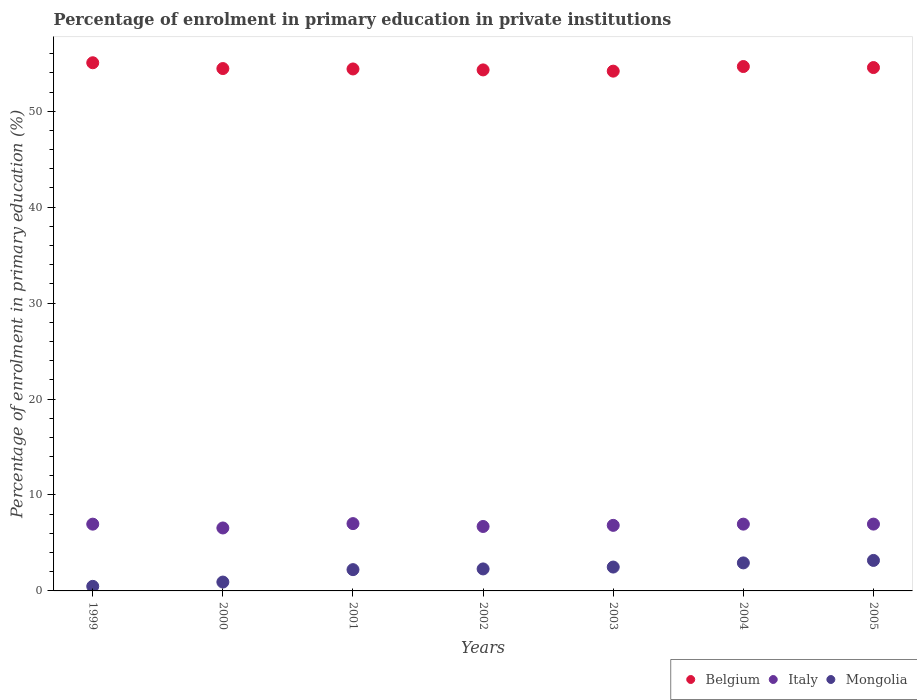What is the percentage of enrolment in primary education in Mongolia in 1999?
Keep it short and to the point. 0.48. Across all years, what is the maximum percentage of enrolment in primary education in Mongolia?
Offer a very short reply. 3.18. Across all years, what is the minimum percentage of enrolment in primary education in Belgium?
Provide a succinct answer. 54.18. In which year was the percentage of enrolment in primary education in Mongolia minimum?
Your response must be concise. 1999. What is the total percentage of enrolment in primary education in Italy in the graph?
Your response must be concise. 48.02. What is the difference between the percentage of enrolment in primary education in Italy in 2002 and that in 2005?
Provide a succinct answer. -0.25. What is the difference between the percentage of enrolment in primary education in Belgium in 2004 and the percentage of enrolment in primary education in Italy in 2003?
Your response must be concise. 47.83. What is the average percentage of enrolment in primary education in Belgium per year?
Offer a terse response. 54.52. In the year 2003, what is the difference between the percentage of enrolment in primary education in Belgium and percentage of enrolment in primary education in Mongolia?
Your answer should be very brief. 51.69. What is the ratio of the percentage of enrolment in primary education in Mongolia in 2002 to that in 2004?
Give a very brief answer. 0.79. Is the difference between the percentage of enrolment in primary education in Belgium in 1999 and 2005 greater than the difference between the percentage of enrolment in primary education in Mongolia in 1999 and 2005?
Ensure brevity in your answer.  Yes. What is the difference between the highest and the second highest percentage of enrolment in primary education in Belgium?
Provide a succinct answer. 0.39. What is the difference between the highest and the lowest percentage of enrolment in primary education in Belgium?
Your answer should be very brief. 0.87. In how many years, is the percentage of enrolment in primary education in Mongolia greater than the average percentage of enrolment in primary education in Mongolia taken over all years?
Your answer should be very brief. 5. Does the graph contain grids?
Make the answer very short. No. Where does the legend appear in the graph?
Your answer should be very brief. Bottom right. How many legend labels are there?
Offer a terse response. 3. What is the title of the graph?
Offer a terse response. Percentage of enrolment in primary education in private institutions. What is the label or title of the Y-axis?
Your answer should be compact. Percentage of enrolment in primary education (%). What is the Percentage of enrolment in primary education (%) of Belgium in 1999?
Your answer should be compact. 55.05. What is the Percentage of enrolment in primary education (%) in Italy in 1999?
Offer a very short reply. 6.96. What is the Percentage of enrolment in primary education (%) of Mongolia in 1999?
Provide a short and direct response. 0.48. What is the Percentage of enrolment in primary education (%) in Belgium in 2000?
Provide a short and direct response. 54.45. What is the Percentage of enrolment in primary education (%) in Italy in 2000?
Your response must be concise. 6.56. What is the Percentage of enrolment in primary education (%) in Mongolia in 2000?
Keep it short and to the point. 0.92. What is the Percentage of enrolment in primary education (%) of Belgium in 2001?
Make the answer very short. 54.41. What is the Percentage of enrolment in primary education (%) of Italy in 2001?
Your answer should be very brief. 7.02. What is the Percentage of enrolment in primary education (%) of Mongolia in 2001?
Your answer should be very brief. 2.22. What is the Percentage of enrolment in primary education (%) in Belgium in 2002?
Offer a very short reply. 54.31. What is the Percentage of enrolment in primary education (%) of Italy in 2002?
Provide a short and direct response. 6.72. What is the Percentage of enrolment in primary education (%) in Mongolia in 2002?
Provide a short and direct response. 2.29. What is the Percentage of enrolment in primary education (%) of Belgium in 2003?
Offer a terse response. 54.18. What is the Percentage of enrolment in primary education (%) in Italy in 2003?
Keep it short and to the point. 6.83. What is the Percentage of enrolment in primary education (%) in Mongolia in 2003?
Your answer should be compact. 2.49. What is the Percentage of enrolment in primary education (%) in Belgium in 2004?
Your response must be concise. 54.66. What is the Percentage of enrolment in primary education (%) of Italy in 2004?
Make the answer very short. 6.96. What is the Percentage of enrolment in primary education (%) in Mongolia in 2004?
Provide a succinct answer. 2.92. What is the Percentage of enrolment in primary education (%) of Belgium in 2005?
Your answer should be very brief. 54.55. What is the Percentage of enrolment in primary education (%) of Italy in 2005?
Your answer should be compact. 6.97. What is the Percentage of enrolment in primary education (%) of Mongolia in 2005?
Keep it short and to the point. 3.18. Across all years, what is the maximum Percentage of enrolment in primary education (%) in Belgium?
Your response must be concise. 55.05. Across all years, what is the maximum Percentage of enrolment in primary education (%) in Italy?
Your response must be concise. 7.02. Across all years, what is the maximum Percentage of enrolment in primary education (%) in Mongolia?
Your response must be concise. 3.18. Across all years, what is the minimum Percentage of enrolment in primary education (%) in Belgium?
Make the answer very short. 54.18. Across all years, what is the minimum Percentage of enrolment in primary education (%) of Italy?
Offer a very short reply. 6.56. Across all years, what is the minimum Percentage of enrolment in primary education (%) of Mongolia?
Give a very brief answer. 0.48. What is the total Percentage of enrolment in primary education (%) of Belgium in the graph?
Keep it short and to the point. 381.61. What is the total Percentage of enrolment in primary education (%) of Italy in the graph?
Offer a very short reply. 48.02. What is the total Percentage of enrolment in primary education (%) of Mongolia in the graph?
Make the answer very short. 14.5. What is the difference between the Percentage of enrolment in primary education (%) of Belgium in 1999 and that in 2000?
Provide a succinct answer. 0.6. What is the difference between the Percentage of enrolment in primary education (%) of Italy in 1999 and that in 2000?
Your answer should be compact. 0.4. What is the difference between the Percentage of enrolment in primary education (%) of Mongolia in 1999 and that in 2000?
Your answer should be compact. -0.45. What is the difference between the Percentage of enrolment in primary education (%) of Belgium in 1999 and that in 2001?
Your answer should be very brief. 0.65. What is the difference between the Percentage of enrolment in primary education (%) in Italy in 1999 and that in 2001?
Keep it short and to the point. -0.06. What is the difference between the Percentage of enrolment in primary education (%) of Mongolia in 1999 and that in 2001?
Provide a succinct answer. -1.74. What is the difference between the Percentage of enrolment in primary education (%) in Belgium in 1999 and that in 2002?
Offer a very short reply. 0.75. What is the difference between the Percentage of enrolment in primary education (%) in Italy in 1999 and that in 2002?
Ensure brevity in your answer.  0.24. What is the difference between the Percentage of enrolment in primary education (%) in Mongolia in 1999 and that in 2002?
Give a very brief answer. -1.82. What is the difference between the Percentage of enrolment in primary education (%) in Belgium in 1999 and that in 2003?
Keep it short and to the point. 0.87. What is the difference between the Percentage of enrolment in primary education (%) in Italy in 1999 and that in 2003?
Make the answer very short. 0.13. What is the difference between the Percentage of enrolment in primary education (%) of Mongolia in 1999 and that in 2003?
Your answer should be compact. -2.01. What is the difference between the Percentage of enrolment in primary education (%) of Belgium in 1999 and that in 2004?
Keep it short and to the point. 0.39. What is the difference between the Percentage of enrolment in primary education (%) in Italy in 1999 and that in 2004?
Give a very brief answer. -0. What is the difference between the Percentage of enrolment in primary education (%) of Mongolia in 1999 and that in 2004?
Provide a short and direct response. -2.44. What is the difference between the Percentage of enrolment in primary education (%) of Belgium in 1999 and that in 2005?
Your response must be concise. 0.5. What is the difference between the Percentage of enrolment in primary education (%) of Italy in 1999 and that in 2005?
Provide a succinct answer. -0.01. What is the difference between the Percentage of enrolment in primary education (%) of Mongolia in 1999 and that in 2005?
Provide a short and direct response. -2.7. What is the difference between the Percentage of enrolment in primary education (%) of Belgium in 2000 and that in 2001?
Ensure brevity in your answer.  0.04. What is the difference between the Percentage of enrolment in primary education (%) of Italy in 2000 and that in 2001?
Your answer should be compact. -0.45. What is the difference between the Percentage of enrolment in primary education (%) in Mongolia in 2000 and that in 2001?
Ensure brevity in your answer.  -1.29. What is the difference between the Percentage of enrolment in primary education (%) in Belgium in 2000 and that in 2002?
Provide a succinct answer. 0.14. What is the difference between the Percentage of enrolment in primary education (%) in Italy in 2000 and that in 2002?
Your answer should be compact. -0.16. What is the difference between the Percentage of enrolment in primary education (%) in Mongolia in 2000 and that in 2002?
Your response must be concise. -1.37. What is the difference between the Percentage of enrolment in primary education (%) in Belgium in 2000 and that in 2003?
Provide a succinct answer. 0.27. What is the difference between the Percentage of enrolment in primary education (%) in Italy in 2000 and that in 2003?
Provide a succinct answer. -0.27. What is the difference between the Percentage of enrolment in primary education (%) in Mongolia in 2000 and that in 2003?
Give a very brief answer. -1.56. What is the difference between the Percentage of enrolment in primary education (%) of Belgium in 2000 and that in 2004?
Provide a short and direct response. -0.21. What is the difference between the Percentage of enrolment in primary education (%) of Italy in 2000 and that in 2004?
Give a very brief answer. -0.4. What is the difference between the Percentage of enrolment in primary education (%) in Mongolia in 2000 and that in 2004?
Your answer should be compact. -2. What is the difference between the Percentage of enrolment in primary education (%) of Belgium in 2000 and that in 2005?
Offer a terse response. -0.1. What is the difference between the Percentage of enrolment in primary education (%) of Italy in 2000 and that in 2005?
Give a very brief answer. -0.4. What is the difference between the Percentage of enrolment in primary education (%) in Mongolia in 2000 and that in 2005?
Make the answer very short. -2.26. What is the difference between the Percentage of enrolment in primary education (%) in Belgium in 2001 and that in 2002?
Offer a terse response. 0.1. What is the difference between the Percentage of enrolment in primary education (%) of Italy in 2001 and that in 2002?
Provide a short and direct response. 0.3. What is the difference between the Percentage of enrolment in primary education (%) in Mongolia in 2001 and that in 2002?
Your response must be concise. -0.08. What is the difference between the Percentage of enrolment in primary education (%) in Belgium in 2001 and that in 2003?
Give a very brief answer. 0.23. What is the difference between the Percentage of enrolment in primary education (%) in Italy in 2001 and that in 2003?
Make the answer very short. 0.18. What is the difference between the Percentage of enrolment in primary education (%) in Mongolia in 2001 and that in 2003?
Provide a succinct answer. -0.27. What is the difference between the Percentage of enrolment in primary education (%) in Belgium in 2001 and that in 2004?
Give a very brief answer. -0.25. What is the difference between the Percentage of enrolment in primary education (%) of Italy in 2001 and that in 2004?
Ensure brevity in your answer.  0.05. What is the difference between the Percentage of enrolment in primary education (%) in Mongolia in 2001 and that in 2004?
Provide a succinct answer. -0.7. What is the difference between the Percentage of enrolment in primary education (%) of Belgium in 2001 and that in 2005?
Make the answer very short. -0.15. What is the difference between the Percentage of enrolment in primary education (%) of Italy in 2001 and that in 2005?
Give a very brief answer. 0.05. What is the difference between the Percentage of enrolment in primary education (%) of Mongolia in 2001 and that in 2005?
Keep it short and to the point. -0.96. What is the difference between the Percentage of enrolment in primary education (%) of Belgium in 2002 and that in 2003?
Your answer should be very brief. 0.13. What is the difference between the Percentage of enrolment in primary education (%) in Italy in 2002 and that in 2003?
Offer a very short reply. -0.12. What is the difference between the Percentage of enrolment in primary education (%) in Mongolia in 2002 and that in 2003?
Provide a succinct answer. -0.19. What is the difference between the Percentage of enrolment in primary education (%) of Belgium in 2002 and that in 2004?
Provide a short and direct response. -0.35. What is the difference between the Percentage of enrolment in primary education (%) in Italy in 2002 and that in 2004?
Offer a very short reply. -0.24. What is the difference between the Percentage of enrolment in primary education (%) in Mongolia in 2002 and that in 2004?
Provide a short and direct response. -0.63. What is the difference between the Percentage of enrolment in primary education (%) of Belgium in 2002 and that in 2005?
Your answer should be very brief. -0.25. What is the difference between the Percentage of enrolment in primary education (%) of Italy in 2002 and that in 2005?
Your answer should be compact. -0.25. What is the difference between the Percentage of enrolment in primary education (%) of Mongolia in 2002 and that in 2005?
Make the answer very short. -0.89. What is the difference between the Percentage of enrolment in primary education (%) in Belgium in 2003 and that in 2004?
Make the answer very short. -0.48. What is the difference between the Percentage of enrolment in primary education (%) of Italy in 2003 and that in 2004?
Provide a succinct answer. -0.13. What is the difference between the Percentage of enrolment in primary education (%) in Mongolia in 2003 and that in 2004?
Your answer should be very brief. -0.43. What is the difference between the Percentage of enrolment in primary education (%) in Belgium in 2003 and that in 2005?
Provide a short and direct response. -0.37. What is the difference between the Percentage of enrolment in primary education (%) in Italy in 2003 and that in 2005?
Make the answer very short. -0.13. What is the difference between the Percentage of enrolment in primary education (%) in Mongolia in 2003 and that in 2005?
Offer a terse response. -0.69. What is the difference between the Percentage of enrolment in primary education (%) of Belgium in 2004 and that in 2005?
Make the answer very short. 0.11. What is the difference between the Percentage of enrolment in primary education (%) in Italy in 2004 and that in 2005?
Give a very brief answer. -0. What is the difference between the Percentage of enrolment in primary education (%) of Mongolia in 2004 and that in 2005?
Provide a short and direct response. -0.26. What is the difference between the Percentage of enrolment in primary education (%) of Belgium in 1999 and the Percentage of enrolment in primary education (%) of Italy in 2000?
Your answer should be very brief. 48.49. What is the difference between the Percentage of enrolment in primary education (%) in Belgium in 1999 and the Percentage of enrolment in primary education (%) in Mongolia in 2000?
Give a very brief answer. 54.13. What is the difference between the Percentage of enrolment in primary education (%) in Italy in 1999 and the Percentage of enrolment in primary education (%) in Mongolia in 2000?
Offer a terse response. 6.04. What is the difference between the Percentage of enrolment in primary education (%) of Belgium in 1999 and the Percentage of enrolment in primary education (%) of Italy in 2001?
Offer a terse response. 48.04. What is the difference between the Percentage of enrolment in primary education (%) of Belgium in 1999 and the Percentage of enrolment in primary education (%) of Mongolia in 2001?
Offer a very short reply. 52.84. What is the difference between the Percentage of enrolment in primary education (%) in Italy in 1999 and the Percentage of enrolment in primary education (%) in Mongolia in 2001?
Make the answer very short. 4.74. What is the difference between the Percentage of enrolment in primary education (%) of Belgium in 1999 and the Percentage of enrolment in primary education (%) of Italy in 2002?
Provide a short and direct response. 48.34. What is the difference between the Percentage of enrolment in primary education (%) in Belgium in 1999 and the Percentage of enrolment in primary education (%) in Mongolia in 2002?
Offer a very short reply. 52.76. What is the difference between the Percentage of enrolment in primary education (%) of Italy in 1999 and the Percentage of enrolment in primary education (%) of Mongolia in 2002?
Give a very brief answer. 4.67. What is the difference between the Percentage of enrolment in primary education (%) of Belgium in 1999 and the Percentage of enrolment in primary education (%) of Italy in 2003?
Give a very brief answer. 48.22. What is the difference between the Percentage of enrolment in primary education (%) in Belgium in 1999 and the Percentage of enrolment in primary education (%) in Mongolia in 2003?
Give a very brief answer. 52.57. What is the difference between the Percentage of enrolment in primary education (%) in Italy in 1999 and the Percentage of enrolment in primary education (%) in Mongolia in 2003?
Give a very brief answer. 4.47. What is the difference between the Percentage of enrolment in primary education (%) in Belgium in 1999 and the Percentage of enrolment in primary education (%) in Italy in 2004?
Keep it short and to the point. 48.09. What is the difference between the Percentage of enrolment in primary education (%) in Belgium in 1999 and the Percentage of enrolment in primary education (%) in Mongolia in 2004?
Your answer should be compact. 52.13. What is the difference between the Percentage of enrolment in primary education (%) of Italy in 1999 and the Percentage of enrolment in primary education (%) of Mongolia in 2004?
Keep it short and to the point. 4.04. What is the difference between the Percentage of enrolment in primary education (%) in Belgium in 1999 and the Percentage of enrolment in primary education (%) in Italy in 2005?
Your answer should be very brief. 48.09. What is the difference between the Percentage of enrolment in primary education (%) of Belgium in 1999 and the Percentage of enrolment in primary education (%) of Mongolia in 2005?
Keep it short and to the point. 51.87. What is the difference between the Percentage of enrolment in primary education (%) in Italy in 1999 and the Percentage of enrolment in primary education (%) in Mongolia in 2005?
Offer a terse response. 3.78. What is the difference between the Percentage of enrolment in primary education (%) in Belgium in 2000 and the Percentage of enrolment in primary education (%) in Italy in 2001?
Your response must be concise. 47.43. What is the difference between the Percentage of enrolment in primary education (%) of Belgium in 2000 and the Percentage of enrolment in primary education (%) of Mongolia in 2001?
Provide a short and direct response. 52.23. What is the difference between the Percentage of enrolment in primary education (%) in Italy in 2000 and the Percentage of enrolment in primary education (%) in Mongolia in 2001?
Ensure brevity in your answer.  4.34. What is the difference between the Percentage of enrolment in primary education (%) in Belgium in 2000 and the Percentage of enrolment in primary education (%) in Italy in 2002?
Keep it short and to the point. 47.73. What is the difference between the Percentage of enrolment in primary education (%) of Belgium in 2000 and the Percentage of enrolment in primary education (%) of Mongolia in 2002?
Keep it short and to the point. 52.16. What is the difference between the Percentage of enrolment in primary education (%) in Italy in 2000 and the Percentage of enrolment in primary education (%) in Mongolia in 2002?
Your answer should be compact. 4.27. What is the difference between the Percentage of enrolment in primary education (%) in Belgium in 2000 and the Percentage of enrolment in primary education (%) in Italy in 2003?
Your response must be concise. 47.61. What is the difference between the Percentage of enrolment in primary education (%) of Belgium in 2000 and the Percentage of enrolment in primary education (%) of Mongolia in 2003?
Make the answer very short. 51.96. What is the difference between the Percentage of enrolment in primary education (%) in Italy in 2000 and the Percentage of enrolment in primary education (%) in Mongolia in 2003?
Offer a very short reply. 4.07. What is the difference between the Percentage of enrolment in primary education (%) in Belgium in 2000 and the Percentage of enrolment in primary education (%) in Italy in 2004?
Your answer should be compact. 47.49. What is the difference between the Percentage of enrolment in primary education (%) of Belgium in 2000 and the Percentage of enrolment in primary education (%) of Mongolia in 2004?
Offer a terse response. 51.53. What is the difference between the Percentage of enrolment in primary education (%) in Italy in 2000 and the Percentage of enrolment in primary education (%) in Mongolia in 2004?
Keep it short and to the point. 3.64. What is the difference between the Percentage of enrolment in primary education (%) in Belgium in 2000 and the Percentage of enrolment in primary education (%) in Italy in 2005?
Your answer should be very brief. 47.48. What is the difference between the Percentage of enrolment in primary education (%) of Belgium in 2000 and the Percentage of enrolment in primary education (%) of Mongolia in 2005?
Ensure brevity in your answer.  51.27. What is the difference between the Percentage of enrolment in primary education (%) in Italy in 2000 and the Percentage of enrolment in primary education (%) in Mongolia in 2005?
Your response must be concise. 3.38. What is the difference between the Percentage of enrolment in primary education (%) of Belgium in 2001 and the Percentage of enrolment in primary education (%) of Italy in 2002?
Provide a succinct answer. 47.69. What is the difference between the Percentage of enrolment in primary education (%) in Belgium in 2001 and the Percentage of enrolment in primary education (%) in Mongolia in 2002?
Your answer should be very brief. 52.11. What is the difference between the Percentage of enrolment in primary education (%) in Italy in 2001 and the Percentage of enrolment in primary education (%) in Mongolia in 2002?
Your response must be concise. 4.72. What is the difference between the Percentage of enrolment in primary education (%) of Belgium in 2001 and the Percentage of enrolment in primary education (%) of Italy in 2003?
Your answer should be very brief. 47.57. What is the difference between the Percentage of enrolment in primary education (%) of Belgium in 2001 and the Percentage of enrolment in primary education (%) of Mongolia in 2003?
Your response must be concise. 51.92. What is the difference between the Percentage of enrolment in primary education (%) in Italy in 2001 and the Percentage of enrolment in primary education (%) in Mongolia in 2003?
Your answer should be very brief. 4.53. What is the difference between the Percentage of enrolment in primary education (%) in Belgium in 2001 and the Percentage of enrolment in primary education (%) in Italy in 2004?
Provide a succinct answer. 47.44. What is the difference between the Percentage of enrolment in primary education (%) of Belgium in 2001 and the Percentage of enrolment in primary education (%) of Mongolia in 2004?
Provide a succinct answer. 51.49. What is the difference between the Percentage of enrolment in primary education (%) of Italy in 2001 and the Percentage of enrolment in primary education (%) of Mongolia in 2004?
Give a very brief answer. 4.1. What is the difference between the Percentage of enrolment in primary education (%) of Belgium in 2001 and the Percentage of enrolment in primary education (%) of Italy in 2005?
Your response must be concise. 47.44. What is the difference between the Percentage of enrolment in primary education (%) of Belgium in 2001 and the Percentage of enrolment in primary education (%) of Mongolia in 2005?
Your answer should be compact. 51.23. What is the difference between the Percentage of enrolment in primary education (%) in Italy in 2001 and the Percentage of enrolment in primary education (%) in Mongolia in 2005?
Provide a short and direct response. 3.84. What is the difference between the Percentage of enrolment in primary education (%) in Belgium in 2002 and the Percentage of enrolment in primary education (%) in Italy in 2003?
Give a very brief answer. 47.47. What is the difference between the Percentage of enrolment in primary education (%) of Belgium in 2002 and the Percentage of enrolment in primary education (%) of Mongolia in 2003?
Keep it short and to the point. 51.82. What is the difference between the Percentage of enrolment in primary education (%) in Italy in 2002 and the Percentage of enrolment in primary education (%) in Mongolia in 2003?
Give a very brief answer. 4.23. What is the difference between the Percentage of enrolment in primary education (%) in Belgium in 2002 and the Percentage of enrolment in primary education (%) in Italy in 2004?
Offer a terse response. 47.34. What is the difference between the Percentage of enrolment in primary education (%) of Belgium in 2002 and the Percentage of enrolment in primary education (%) of Mongolia in 2004?
Ensure brevity in your answer.  51.39. What is the difference between the Percentage of enrolment in primary education (%) in Italy in 2002 and the Percentage of enrolment in primary education (%) in Mongolia in 2004?
Offer a very short reply. 3.8. What is the difference between the Percentage of enrolment in primary education (%) in Belgium in 2002 and the Percentage of enrolment in primary education (%) in Italy in 2005?
Give a very brief answer. 47.34. What is the difference between the Percentage of enrolment in primary education (%) in Belgium in 2002 and the Percentage of enrolment in primary education (%) in Mongolia in 2005?
Your answer should be very brief. 51.13. What is the difference between the Percentage of enrolment in primary education (%) of Italy in 2002 and the Percentage of enrolment in primary education (%) of Mongolia in 2005?
Ensure brevity in your answer.  3.54. What is the difference between the Percentage of enrolment in primary education (%) in Belgium in 2003 and the Percentage of enrolment in primary education (%) in Italy in 2004?
Provide a succinct answer. 47.22. What is the difference between the Percentage of enrolment in primary education (%) in Belgium in 2003 and the Percentage of enrolment in primary education (%) in Mongolia in 2004?
Your response must be concise. 51.26. What is the difference between the Percentage of enrolment in primary education (%) of Italy in 2003 and the Percentage of enrolment in primary education (%) of Mongolia in 2004?
Provide a short and direct response. 3.91. What is the difference between the Percentage of enrolment in primary education (%) in Belgium in 2003 and the Percentage of enrolment in primary education (%) in Italy in 2005?
Offer a very short reply. 47.21. What is the difference between the Percentage of enrolment in primary education (%) of Belgium in 2003 and the Percentage of enrolment in primary education (%) of Mongolia in 2005?
Provide a succinct answer. 51. What is the difference between the Percentage of enrolment in primary education (%) of Italy in 2003 and the Percentage of enrolment in primary education (%) of Mongolia in 2005?
Ensure brevity in your answer.  3.65. What is the difference between the Percentage of enrolment in primary education (%) in Belgium in 2004 and the Percentage of enrolment in primary education (%) in Italy in 2005?
Give a very brief answer. 47.69. What is the difference between the Percentage of enrolment in primary education (%) of Belgium in 2004 and the Percentage of enrolment in primary education (%) of Mongolia in 2005?
Offer a very short reply. 51.48. What is the difference between the Percentage of enrolment in primary education (%) of Italy in 2004 and the Percentage of enrolment in primary education (%) of Mongolia in 2005?
Provide a short and direct response. 3.78. What is the average Percentage of enrolment in primary education (%) of Belgium per year?
Provide a short and direct response. 54.52. What is the average Percentage of enrolment in primary education (%) in Italy per year?
Ensure brevity in your answer.  6.86. What is the average Percentage of enrolment in primary education (%) of Mongolia per year?
Make the answer very short. 2.07. In the year 1999, what is the difference between the Percentage of enrolment in primary education (%) of Belgium and Percentage of enrolment in primary education (%) of Italy?
Make the answer very short. 48.09. In the year 1999, what is the difference between the Percentage of enrolment in primary education (%) of Belgium and Percentage of enrolment in primary education (%) of Mongolia?
Keep it short and to the point. 54.58. In the year 1999, what is the difference between the Percentage of enrolment in primary education (%) in Italy and Percentage of enrolment in primary education (%) in Mongolia?
Provide a succinct answer. 6.48. In the year 2000, what is the difference between the Percentage of enrolment in primary education (%) in Belgium and Percentage of enrolment in primary education (%) in Italy?
Offer a very short reply. 47.89. In the year 2000, what is the difference between the Percentage of enrolment in primary education (%) in Belgium and Percentage of enrolment in primary education (%) in Mongolia?
Your response must be concise. 53.53. In the year 2000, what is the difference between the Percentage of enrolment in primary education (%) of Italy and Percentage of enrolment in primary education (%) of Mongolia?
Offer a terse response. 5.64. In the year 2001, what is the difference between the Percentage of enrolment in primary education (%) of Belgium and Percentage of enrolment in primary education (%) of Italy?
Keep it short and to the point. 47.39. In the year 2001, what is the difference between the Percentage of enrolment in primary education (%) of Belgium and Percentage of enrolment in primary education (%) of Mongolia?
Make the answer very short. 52.19. In the year 2001, what is the difference between the Percentage of enrolment in primary education (%) of Italy and Percentage of enrolment in primary education (%) of Mongolia?
Make the answer very short. 4.8. In the year 2002, what is the difference between the Percentage of enrolment in primary education (%) in Belgium and Percentage of enrolment in primary education (%) in Italy?
Offer a very short reply. 47.59. In the year 2002, what is the difference between the Percentage of enrolment in primary education (%) in Belgium and Percentage of enrolment in primary education (%) in Mongolia?
Your answer should be very brief. 52.01. In the year 2002, what is the difference between the Percentage of enrolment in primary education (%) in Italy and Percentage of enrolment in primary education (%) in Mongolia?
Your answer should be very brief. 4.42. In the year 2003, what is the difference between the Percentage of enrolment in primary education (%) of Belgium and Percentage of enrolment in primary education (%) of Italy?
Offer a very short reply. 47.34. In the year 2003, what is the difference between the Percentage of enrolment in primary education (%) of Belgium and Percentage of enrolment in primary education (%) of Mongolia?
Provide a succinct answer. 51.69. In the year 2003, what is the difference between the Percentage of enrolment in primary education (%) of Italy and Percentage of enrolment in primary education (%) of Mongolia?
Give a very brief answer. 4.35. In the year 2004, what is the difference between the Percentage of enrolment in primary education (%) of Belgium and Percentage of enrolment in primary education (%) of Italy?
Keep it short and to the point. 47.7. In the year 2004, what is the difference between the Percentage of enrolment in primary education (%) of Belgium and Percentage of enrolment in primary education (%) of Mongolia?
Give a very brief answer. 51.74. In the year 2004, what is the difference between the Percentage of enrolment in primary education (%) in Italy and Percentage of enrolment in primary education (%) in Mongolia?
Your answer should be compact. 4.04. In the year 2005, what is the difference between the Percentage of enrolment in primary education (%) of Belgium and Percentage of enrolment in primary education (%) of Italy?
Offer a very short reply. 47.59. In the year 2005, what is the difference between the Percentage of enrolment in primary education (%) in Belgium and Percentage of enrolment in primary education (%) in Mongolia?
Your response must be concise. 51.37. In the year 2005, what is the difference between the Percentage of enrolment in primary education (%) in Italy and Percentage of enrolment in primary education (%) in Mongolia?
Provide a succinct answer. 3.79. What is the ratio of the Percentage of enrolment in primary education (%) of Belgium in 1999 to that in 2000?
Your answer should be compact. 1.01. What is the ratio of the Percentage of enrolment in primary education (%) in Italy in 1999 to that in 2000?
Your response must be concise. 1.06. What is the ratio of the Percentage of enrolment in primary education (%) in Mongolia in 1999 to that in 2000?
Ensure brevity in your answer.  0.52. What is the ratio of the Percentage of enrolment in primary education (%) in Belgium in 1999 to that in 2001?
Offer a terse response. 1.01. What is the ratio of the Percentage of enrolment in primary education (%) in Italy in 1999 to that in 2001?
Provide a succinct answer. 0.99. What is the ratio of the Percentage of enrolment in primary education (%) in Mongolia in 1999 to that in 2001?
Provide a short and direct response. 0.21. What is the ratio of the Percentage of enrolment in primary education (%) in Belgium in 1999 to that in 2002?
Offer a very short reply. 1.01. What is the ratio of the Percentage of enrolment in primary education (%) of Italy in 1999 to that in 2002?
Ensure brevity in your answer.  1.04. What is the ratio of the Percentage of enrolment in primary education (%) of Mongolia in 1999 to that in 2002?
Provide a succinct answer. 0.21. What is the ratio of the Percentage of enrolment in primary education (%) in Belgium in 1999 to that in 2003?
Offer a terse response. 1.02. What is the ratio of the Percentage of enrolment in primary education (%) of Italy in 1999 to that in 2003?
Make the answer very short. 1.02. What is the ratio of the Percentage of enrolment in primary education (%) in Mongolia in 1999 to that in 2003?
Provide a succinct answer. 0.19. What is the ratio of the Percentage of enrolment in primary education (%) of Italy in 1999 to that in 2004?
Make the answer very short. 1. What is the ratio of the Percentage of enrolment in primary education (%) of Mongolia in 1999 to that in 2004?
Provide a short and direct response. 0.16. What is the ratio of the Percentage of enrolment in primary education (%) of Belgium in 1999 to that in 2005?
Offer a very short reply. 1.01. What is the ratio of the Percentage of enrolment in primary education (%) of Mongolia in 1999 to that in 2005?
Your answer should be compact. 0.15. What is the ratio of the Percentage of enrolment in primary education (%) of Belgium in 2000 to that in 2001?
Your answer should be compact. 1. What is the ratio of the Percentage of enrolment in primary education (%) of Italy in 2000 to that in 2001?
Provide a succinct answer. 0.94. What is the ratio of the Percentage of enrolment in primary education (%) in Mongolia in 2000 to that in 2001?
Your answer should be compact. 0.42. What is the ratio of the Percentage of enrolment in primary education (%) of Belgium in 2000 to that in 2002?
Your response must be concise. 1. What is the ratio of the Percentage of enrolment in primary education (%) of Italy in 2000 to that in 2002?
Provide a succinct answer. 0.98. What is the ratio of the Percentage of enrolment in primary education (%) in Mongolia in 2000 to that in 2002?
Offer a very short reply. 0.4. What is the ratio of the Percentage of enrolment in primary education (%) of Italy in 2000 to that in 2003?
Give a very brief answer. 0.96. What is the ratio of the Percentage of enrolment in primary education (%) of Mongolia in 2000 to that in 2003?
Provide a succinct answer. 0.37. What is the ratio of the Percentage of enrolment in primary education (%) of Italy in 2000 to that in 2004?
Your answer should be compact. 0.94. What is the ratio of the Percentage of enrolment in primary education (%) in Mongolia in 2000 to that in 2004?
Provide a short and direct response. 0.32. What is the ratio of the Percentage of enrolment in primary education (%) in Belgium in 2000 to that in 2005?
Your answer should be very brief. 1. What is the ratio of the Percentage of enrolment in primary education (%) in Italy in 2000 to that in 2005?
Make the answer very short. 0.94. What is the ratio of the Percentage of enrolment in primary education (%) of Mongolia in 2000 to that in 2005?
Offer a terse response. 0.29. What is the ratio of the Percentage of enrolment in primary education (%) of Belgium in 2001 to that in 2002?
Offer a terse response. 1. What is the ratio of the Percentage of enrolment in primary education (%) of Italy in 2001 to that in 2002?
Offer a very short reply. 1.04. What is the ratio of the Percentage of enrolment in primary education (%) of Mongolia in 2001 to that in 2002?
Your response must be concise. 0.97. What is the ratio of the Percentage of enrolment in primary education (%) in Belgium in 2001 to that in 2003?
Your answer should be very brief. 1. What is the ratio of the Percentage of enrolment in primary education (%) of Italy in 2001 to that in 2003?
Provide a short and direct response. 1.03. What is the ratio of the Percentage of enrolment in primary education (%) of Mongolia in 2001 to that in 2003?
Your answer should be compact. 0.89. What is the ratio of the Percentage of enrolment in primary education (%) of Belgium in 2001 to that in 2004?
Your response must be concise. 1. What is the ratio of the Percentage of enrolment in primary education (%) in Italy in 2001 to that in 2004?
Ensure brevity in your answer.  1.01. What is the ratio of the Percentage of enrolment in primary education (%) in Mongolia in 2001 to that in 2004?
Give a very brief answer. 0.76. What is the ratio of the Percentage of enrolment in primary education (%) of Belgium in 2001 to that in 2005?
Your answer should be very brief. 1. What is the ratio of the Percentage of enrolment in primary education (%) in Mongolia in 2001 to that in 2005?
Your answer should be very brief. 0.7. What is the ratio of the Percentage of enrolment in primary education (%) of Mongolia in 2002 to that in 2003?
Your response must be concise. 0.92. What is the ratio of the Percentage of enrolment in primary education (%) of Belgium in 2002 to that in 2004?
Make the answer very short. 0.99. What is the ratio of the Percentage of enrolment in primary education (%) of Italy in 2002 to that in 2004?
Offer a terse response. 0.96. What is the ratio of the Percentage of enrolment in primary education (%) in Mongolia in 2002 to that in 2004?
Keep it short and to the point. 0.79. What is the ratio of the Percentage of enrolment in primary education (%) of Italy in 2002 to that in 2005?
Provide a short and direct response. 0.96. What is the ratio of the Percentage of enrolment in primary education (%) in Mongolia in 2002 to that in 2005?
Make the answer very short. 0.72. What is the ratio of the Percentage of enrolment in primary education (%) of Italy in 2003 to that in 2004?
Your answer should be very brief. 0.98. What is the ratio of the Percentage of enrolment in primary education (%) in Mongolia in 2003 to that in 2004?
Your answer should be very brief. 0.85. What is the ratio of the Percentage of enrolment in primary education (%) in Italy in 2003 to that in 2005?
Provide a succinct answer. 0.98. What is the ratio of the Percentage of enrolment in primary education (%) in Mongolia in 2003 to that in 2005?
Your answer should be compact. 0.78. What is the ratio of the Percentage of enrolment in primary education (%) in Belgium in 2004 to that in 2005?
Give a very brief answer. 1. What is the ratio of the Percentage of enrolment in primary education (%) of Italy in 2004 to that in 2005?
Offer a terse response. 1. What is the ratio of the Percentage of enrolment in primary education (%) in Mongolia in 2004 to that in 2005?
Make the answer very short. 0.92. What is the difference between the highest and the second highest Percentage of enrolment in primary education (%) in Belgium?
Offer a very short reply. 0.39. What is the difference between the highest and the second highest Percentage of enrolment in primary education (%) in Italy?
Offer a very short reply. 0.05. What is the difference between the highest and the second highest Percentage of enrolment in primary education (%) in Mongolia?
Your answer should be compact. 0.26. What is the difference between the highest and the lowest Percentage of enrolment in primary education (%) of Belgium?
Give a very brief answer. 0.87. What is the difference between the highest and the lowest Percentage of enrolment in primary education (%) in Italy?
Your response must be concise. 0.45. What is the difference between the highest and the lowest Percentage of enrolment in primary education (%) in Mongolia?
Offer a terse response. 2.7. 